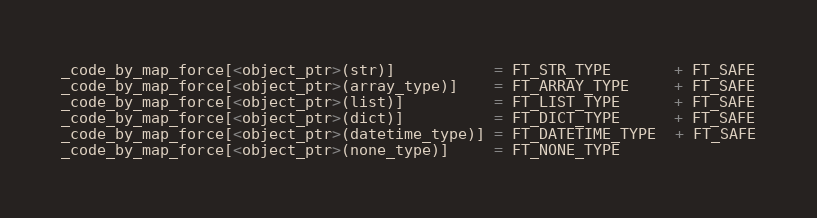Convert code to text. <code><loc_0><loc_0><loc_500><loc_500><_Cython_>_code_by_map_force[<object_ptr>(str)]           = FT_STR_TYPE       + FT_SAFE
_code_by_map_force[<object_ptr>(array_type)]    = FT_ARRAY_TYPE     + FT_SAFE
_code_by_map_force[<object_ptr>(list)]          = FT_LIST_TYPE      + FT_SAFE
_code_by_map_force[<object_ptr>(dict)]          = FT_DICT_TYPE      + FT_SAFE
_code_by_map_force[<object_ptr>(datetime_type)] = FT_DATETIME_TYPE  + FT_SAFE
_code_by_map_force[<object_ptr>(none_type)]     = FT_NONE_TYPE</code> 